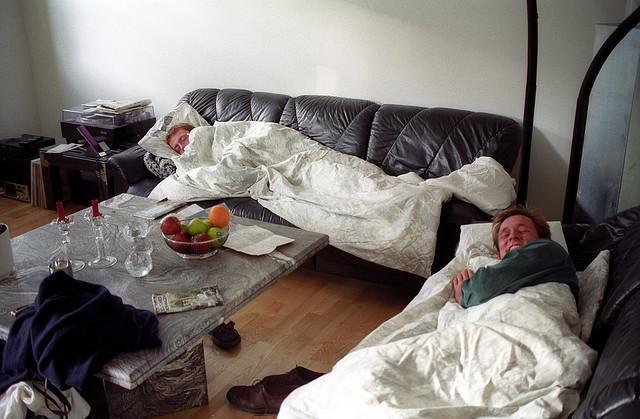What is the bowl holding the fruit made from?
Choose the right answer from the provided options to respond to the question.
Options: Wood, plastic, steel, glass. Glass. 